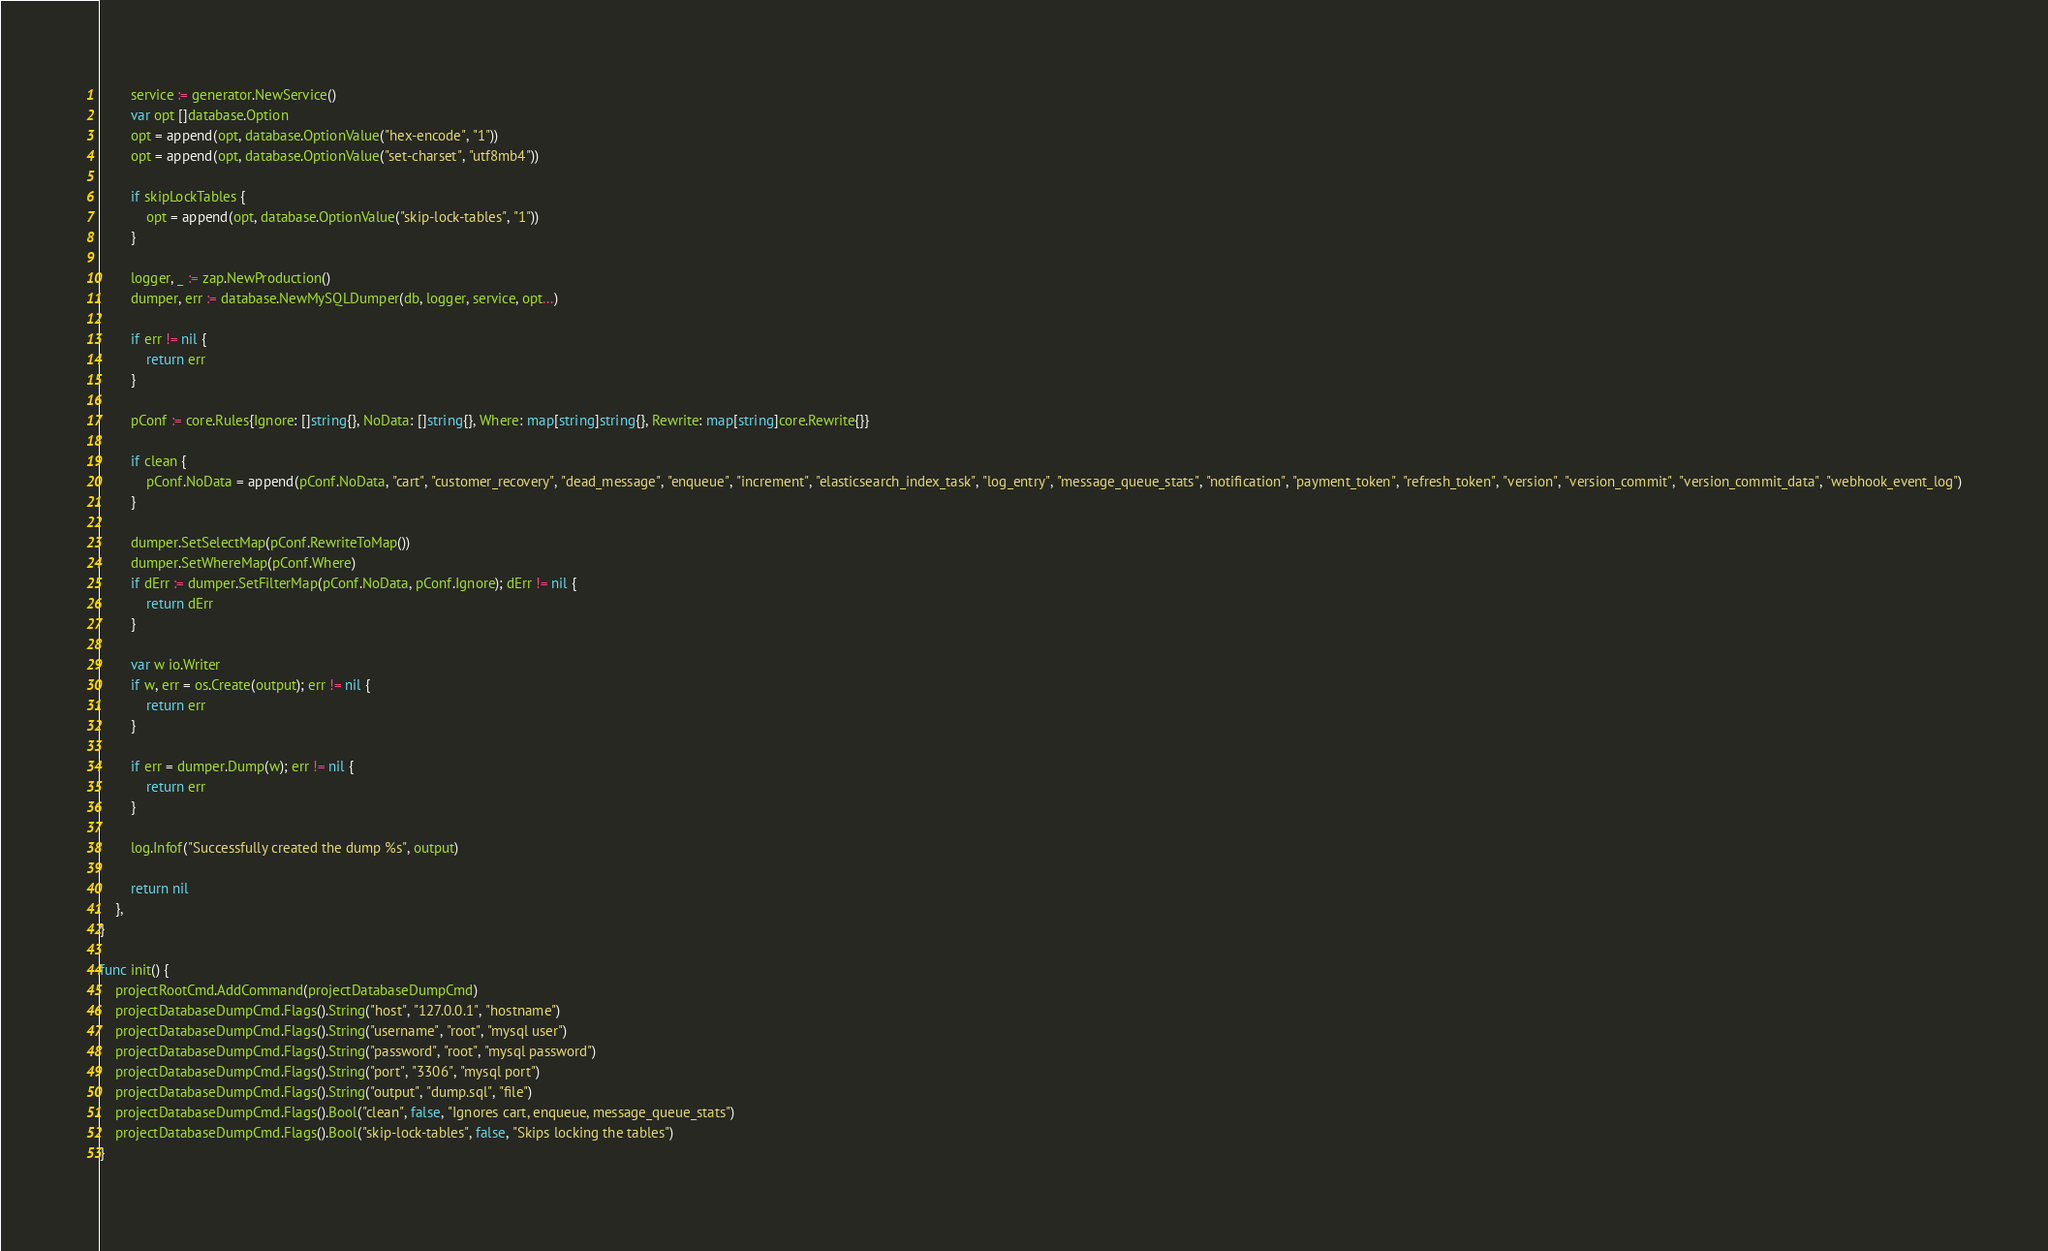Convert code to text. <code><loc_0><loc_0><loc_500><loc_500><_Go_>
		service := generator.NewService()
		var opt []database.Option
		opt = append(opt, database.OptionValue("hex-encode", "1"))
		opt = append(opt, database.OptionValue("set-charset", "utf8mb4"))

		if skipLockTables {
			opt = append(opt, database.OptionValue("skip-lock-tables", "1"))
		}

		logger, _ := zap.NewProduction()
		dumper, err := database.NewMySQLDumper(db, logger, service, opt...)

		if err != nil {
			return err
		}

		pConf := core.Rules{Ignore: []string{}, NoData: []string{}, Where: map[string]string{}, Rewrite: map[string]core.Rewrite{}}

		if clean {
			pConf.NoData = append(pConf.NoData, "cart", "customer_recovery", "dead_message", "enqueue", "increment", "elasticsearch_index_task", "log_entry", "message_queue_stats", "notification", "payment_token", "refresh_token", "version", "version_commit", "version_commit_data", "webhook_event_log")
		}

		dumper.SetSelectMap(pConf.RewriteToMap())
		dumper.SetWhereMap(pConf.Where)
		if dErr := dumper.SetFilterMap(pConf.NoData, pConf.Ignore); dErr != nil {
			return dErr
		}

		var w io.Writer
		if w, err = os.Create(output); err != nil {
			return err
		}

		if err = dumper.Dump(w); err != nil {
			return err
		}

		log.Infof("Successfully created the dump %s", output)

		return nil
	},
}

func init() {
	projectRootCmd.AddCommand(projectDatabaseDumpCmd)
	projectDatabaseDumpCmd.Flags().String("host", "127.0.0.1", "hostname")
	projectDatabaseDumpCmd.Flags().String("username", "root", "mysql user")
	projectDatabaseDumpCmd.Flags().String("password", "root", "mysql password")
	projectDatabaseDumpCmd.Flags().String("port", "3306", "mysql port")
	projectDatabaseDumpCmd.Flags().String("output", "dump.sql", "file")
	projectDatabaseDumpCmd.Flags().Bool("clean", false, "Ignores cart, enqueue, message_queue_stats")
	projectDatabaseDumpCmd.Flags().Bool("skip-lock-tables", false, "Skips locking the tables")
}
</code> 